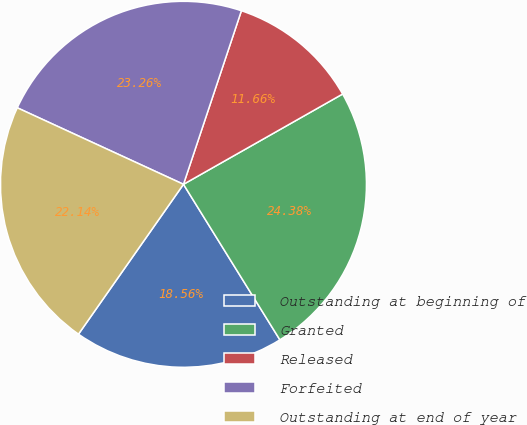Convert chart. <chart><loc_0><loc_0><loc_500><loc_500><pie_chart><fcel>Outstanding at beginning of<fcel>Granted<fcel>Released<fcel>Forfeited<fcel>Outstanding at end of year<nl><fcel>18.56%<fcel>24.38%<fcel>11.66%<fcel>23.26%<fcel>22.14%<nl></chart> 